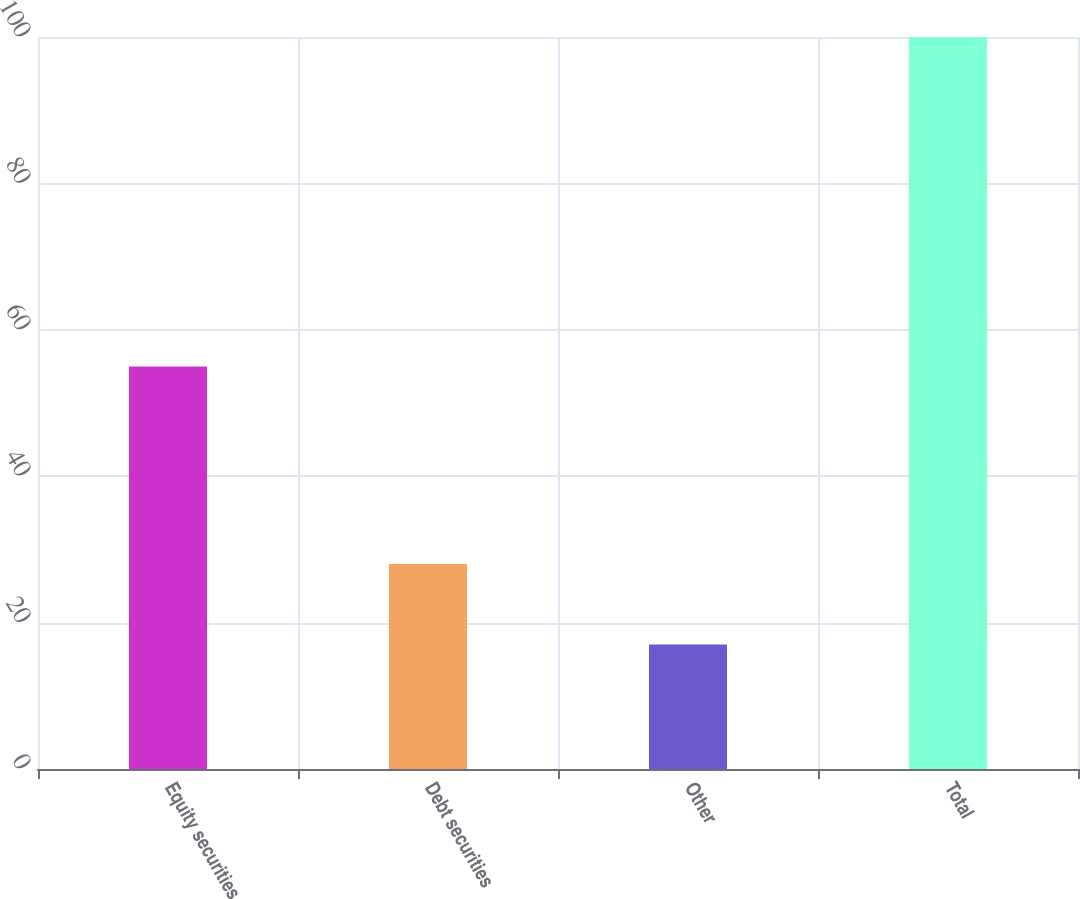<chart> <loc_0><loc_0><loc_500><loc_500><bar_chart><fcel>Equity securities<fcel>Debt securities<fcel>Other<fcel>Total<nl><fcel>55<fcel>28<fcel>17<fcel>100<nl></chart> 